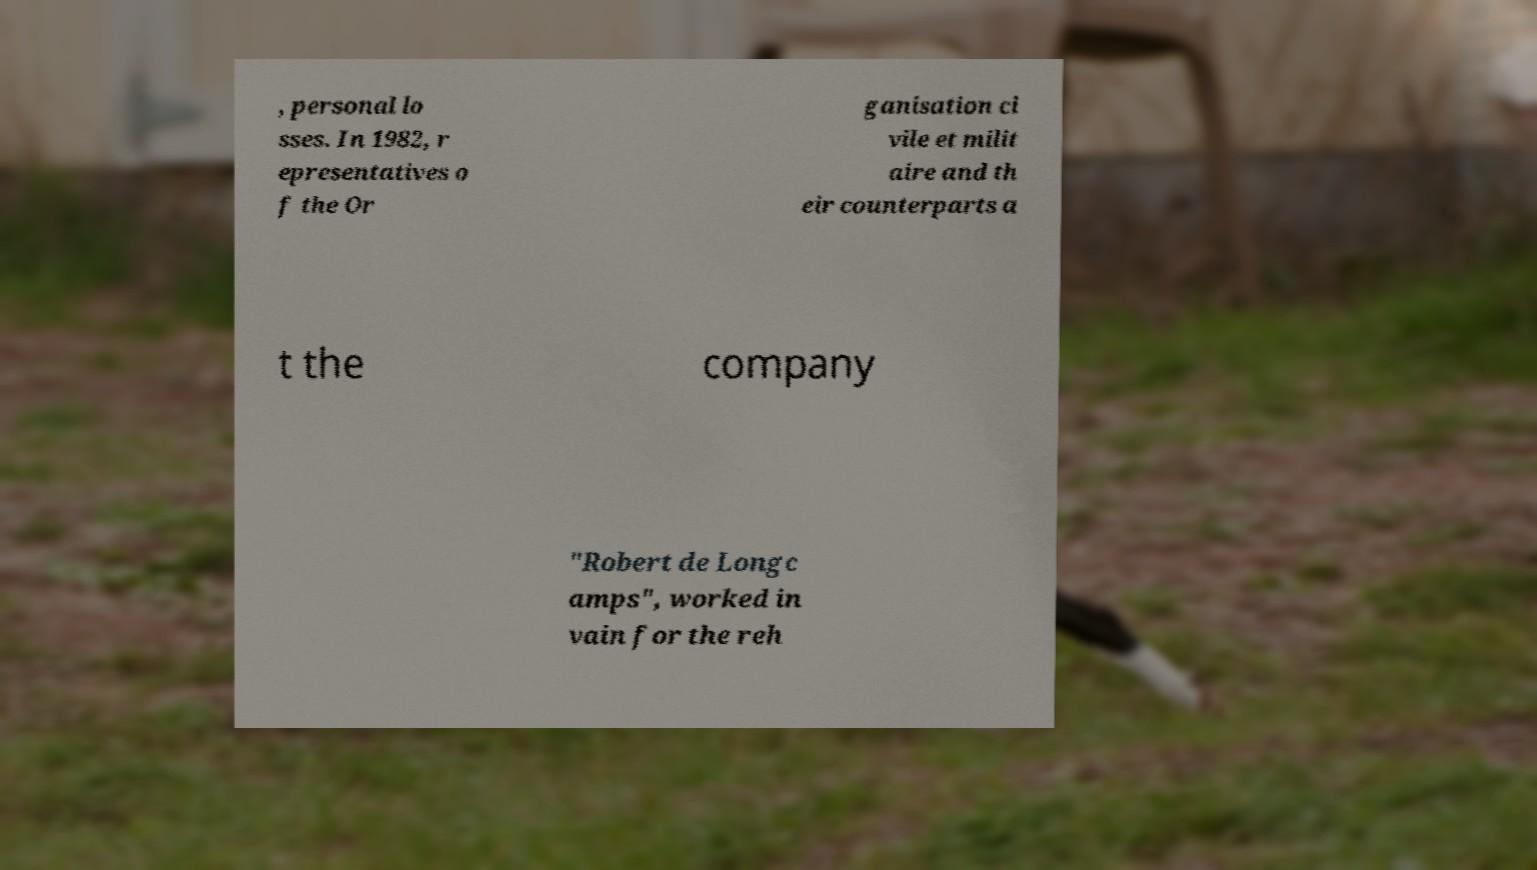Could you extract and type out the text from this image? , personal lo sses. In 1982, r epresentatives o f the Or ganisation ci vile et milit aire and th eir counterparts a t the company "Robert de Longc amps", worked in vain for the reh 